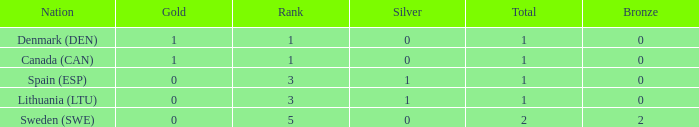Would you be able to parse every entry in this table? {'header': ['Nation', 'Gold', 'Rank', 'Silver', 'Total', 'Bronze'], 'rows': [['Denmark (DEN)', '1', '1', '0', '1', '0'], ['Canada (CAN)', '1', '1', '0', '1', '0'], ['Spain (ESP)', '0', '3', '1', '1', '0'], ['Lithuania (LTU)', '0', '3', '1', '1', '0'], ['Sweden (SWE)', '0', '5', '0', '2', '2']]} What is the number of gold medals for Lithuania (ltu), when the total is more than 1? None. 